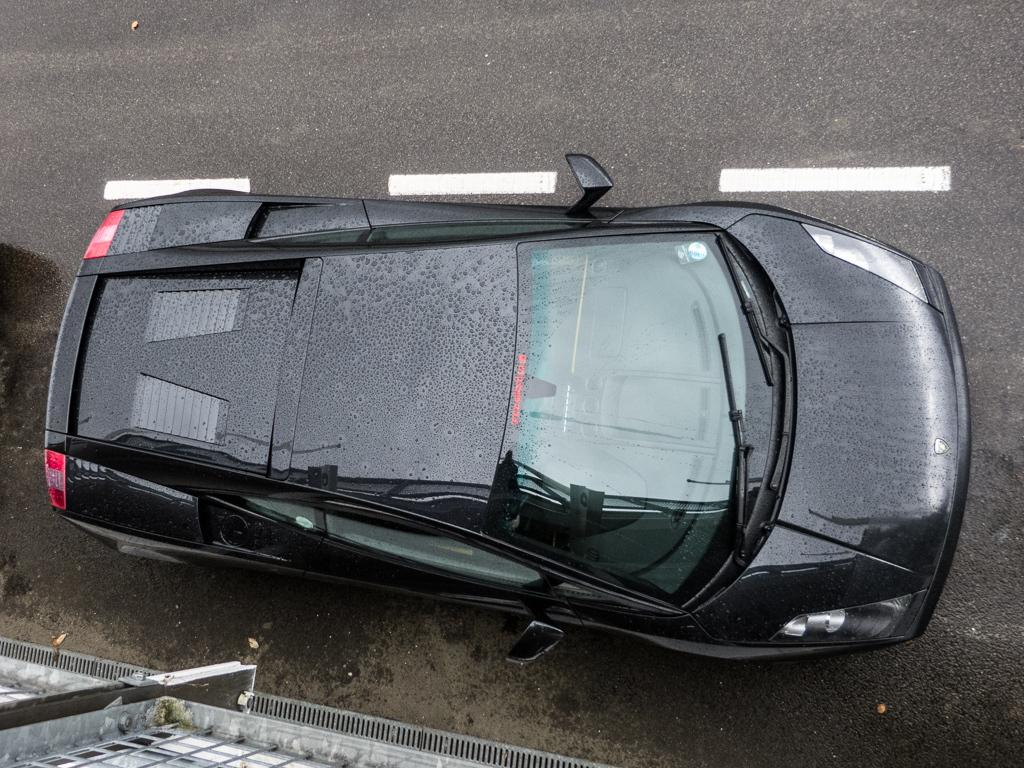What color is the car in the image? The car in the image is black. Where is the car located in the image? The car is parked on a road. What can be seen on the road in the image? Dew is visible on the road. What else is visible in the image besides the car and the road? There is a wall of a building in the image. Is the car in the image capable of printing documents? No, the car in the image is not capable of printing documents; it is a vehicle and not an office machine. 